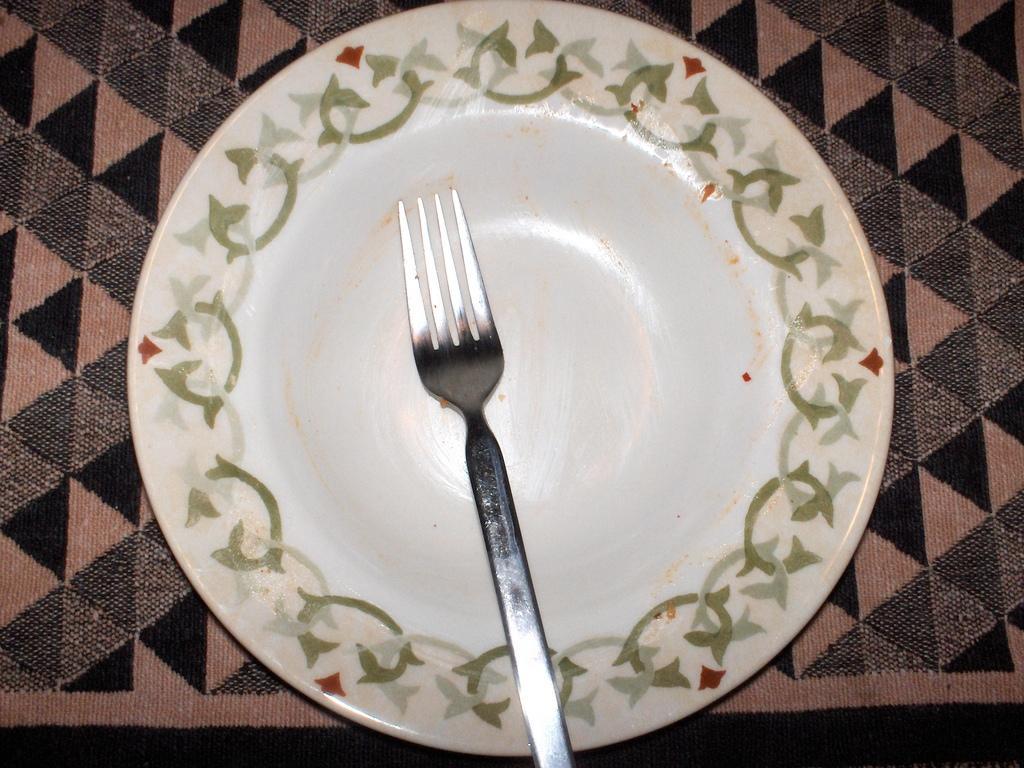Could you give a brief overview of what you see in this image? In this image we can see a fork on a plate placed on the surface. 